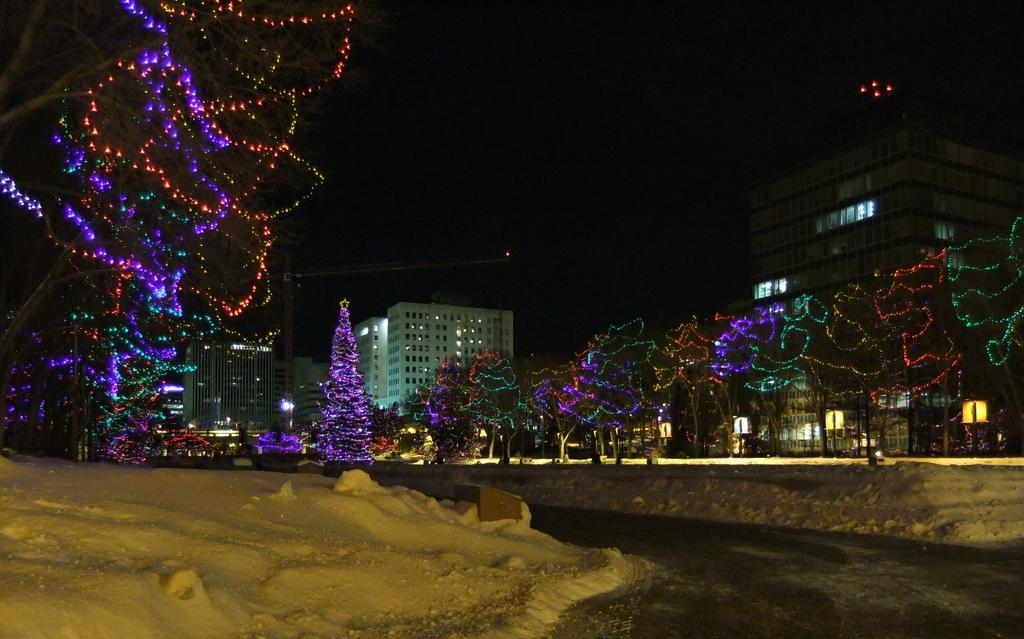What type of weather condition is depicted in the image? There is snow in the image. What can be seen on the trees in the image? The trees have decorative lights in the image. What is visible in the background of the image? There are buildings in the background of the image. What time of day or night does the image appear to be set? The image appears to be set during a dark time of day or night. Can you see any jellyfish swimming in the snow in the image? There are no jellyfish present in the image; it features snow, trees with decorative lights, and buildings in the background. 